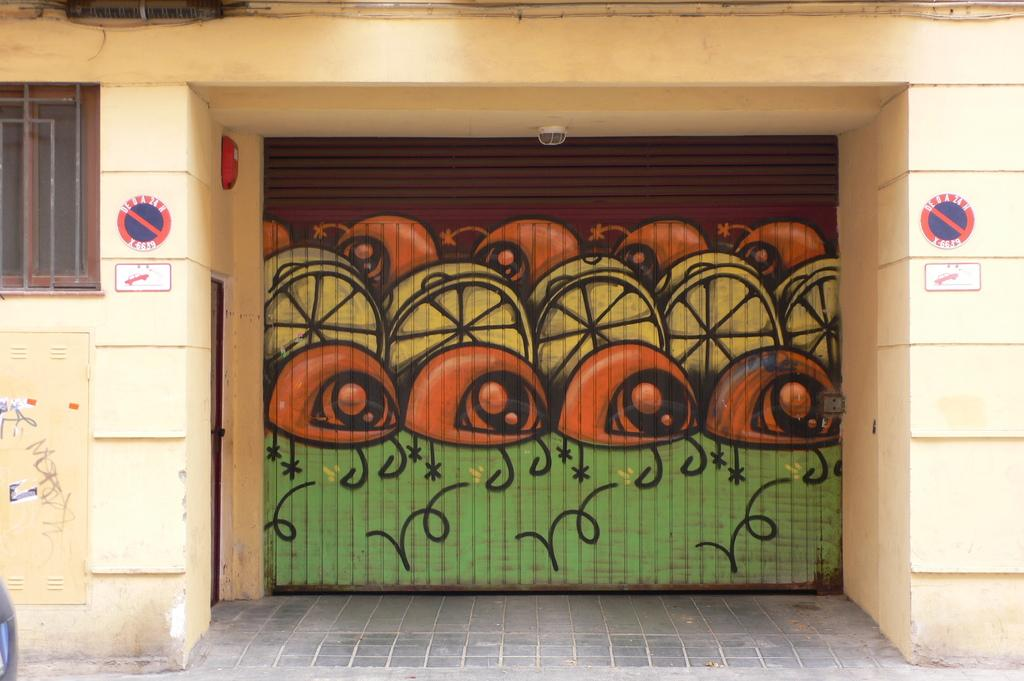What type of opening is located on the left side of the image? There is a window on the left side of the image. What feature is in the middle of the image? There is a shutter in the middle of the image. What type of entrance is on the right side of the image? There is a door on the right side of the image. What type of apparel is being controlled by the fiction in the image? There is no apparel or fiction present in the image. What type of control system is being used to manage the window in the image? The provided facts do not mention any control system for the window; it is simply a window in the image. 